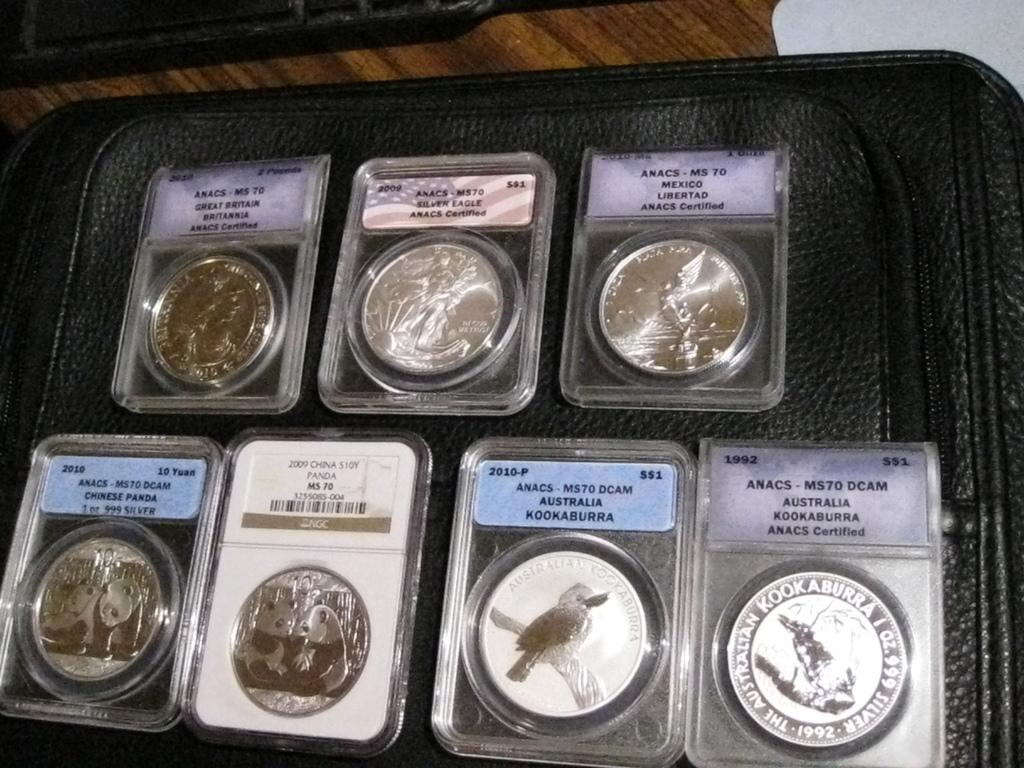<image>
Summarize the visual content of the image. Collection of coins with one saying "Australia Kookaburra" on it. 